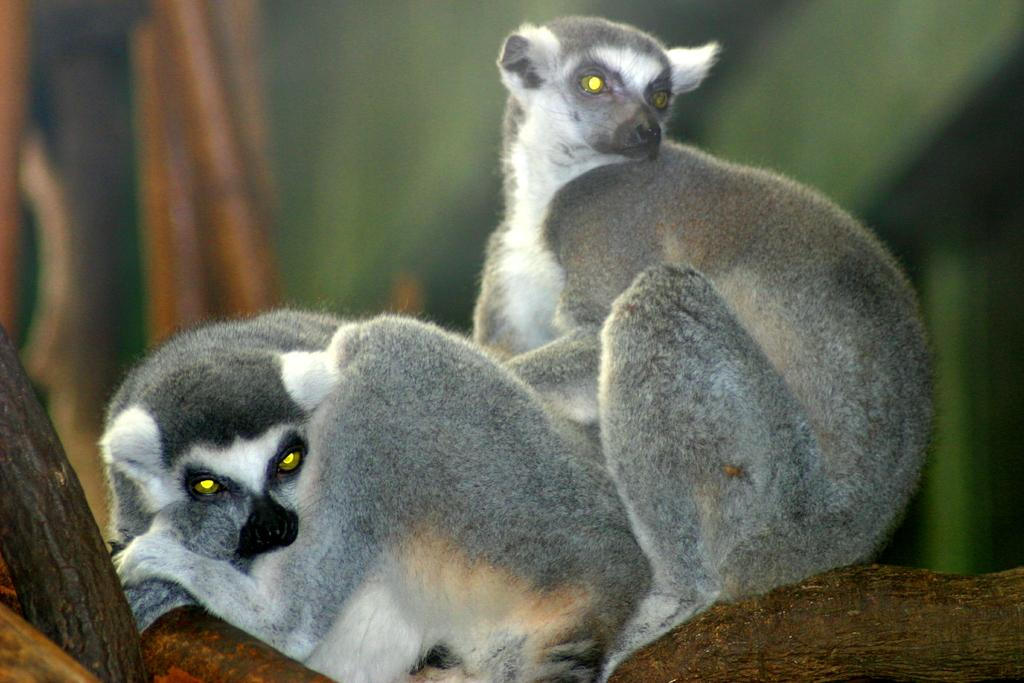How many animals are present in the image? There are two animals in the image. What colors are the animals? The animals are grey, white, cream, and black in color. Where are the animals located in the image? The animals are on a tree branch. What can be observed about the background of the image? The background of the image is blurry, and the background colors are green and brown. What type of pen is the animal holding in the image? There is no pen present in the image; the animals are on a tree branch. What type of ray can be seen swimming in the background of the image? There are no rays visible in the image; the background colors are green and brown. 